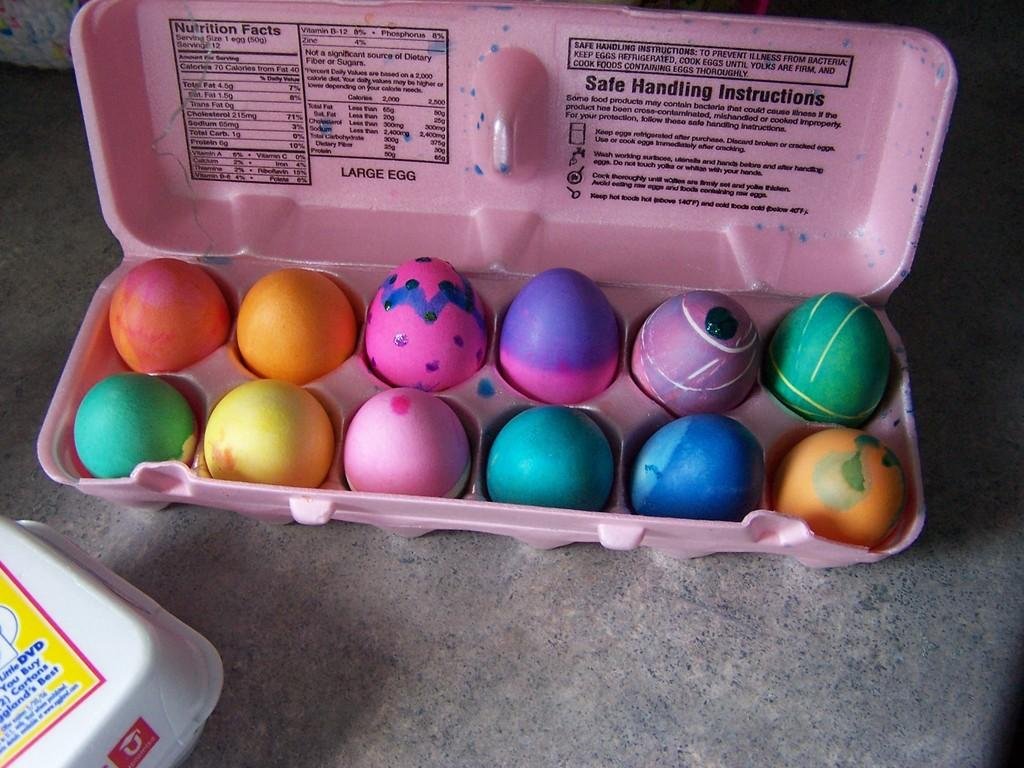What type of objects are present in the image? There are colorful eggs in the image. How are the eggs arranged or stored? The eggs are kept in an egg container. Is there any other object visible in the image? Yes, there is a white color box in the left bottom of the image. What part of the image is trying to get our attention? There is no indication in the image that any part is trying to get our attention. 